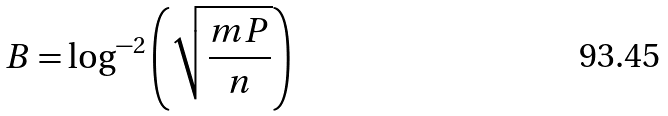<formula> <loc_0><loc_0><loc_500><loc_500>B = \log ^ { - 2 } \left ( \sqrt { \frac { m P } { n } } \right )</formula> 